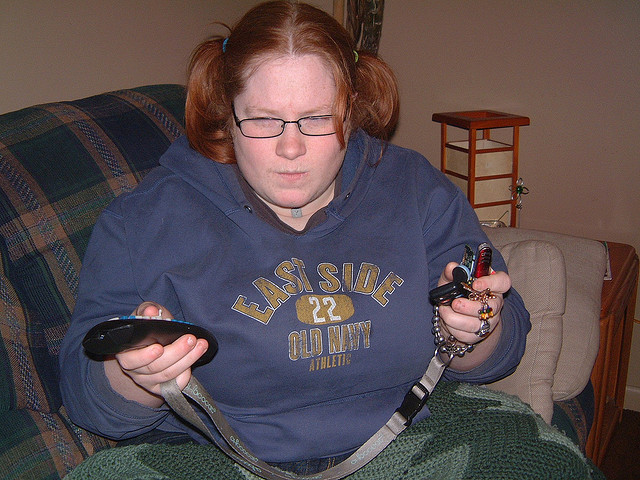Extract all visible text content from this image. EAST SIDE 22 OLD NAVY ATHLETIC 